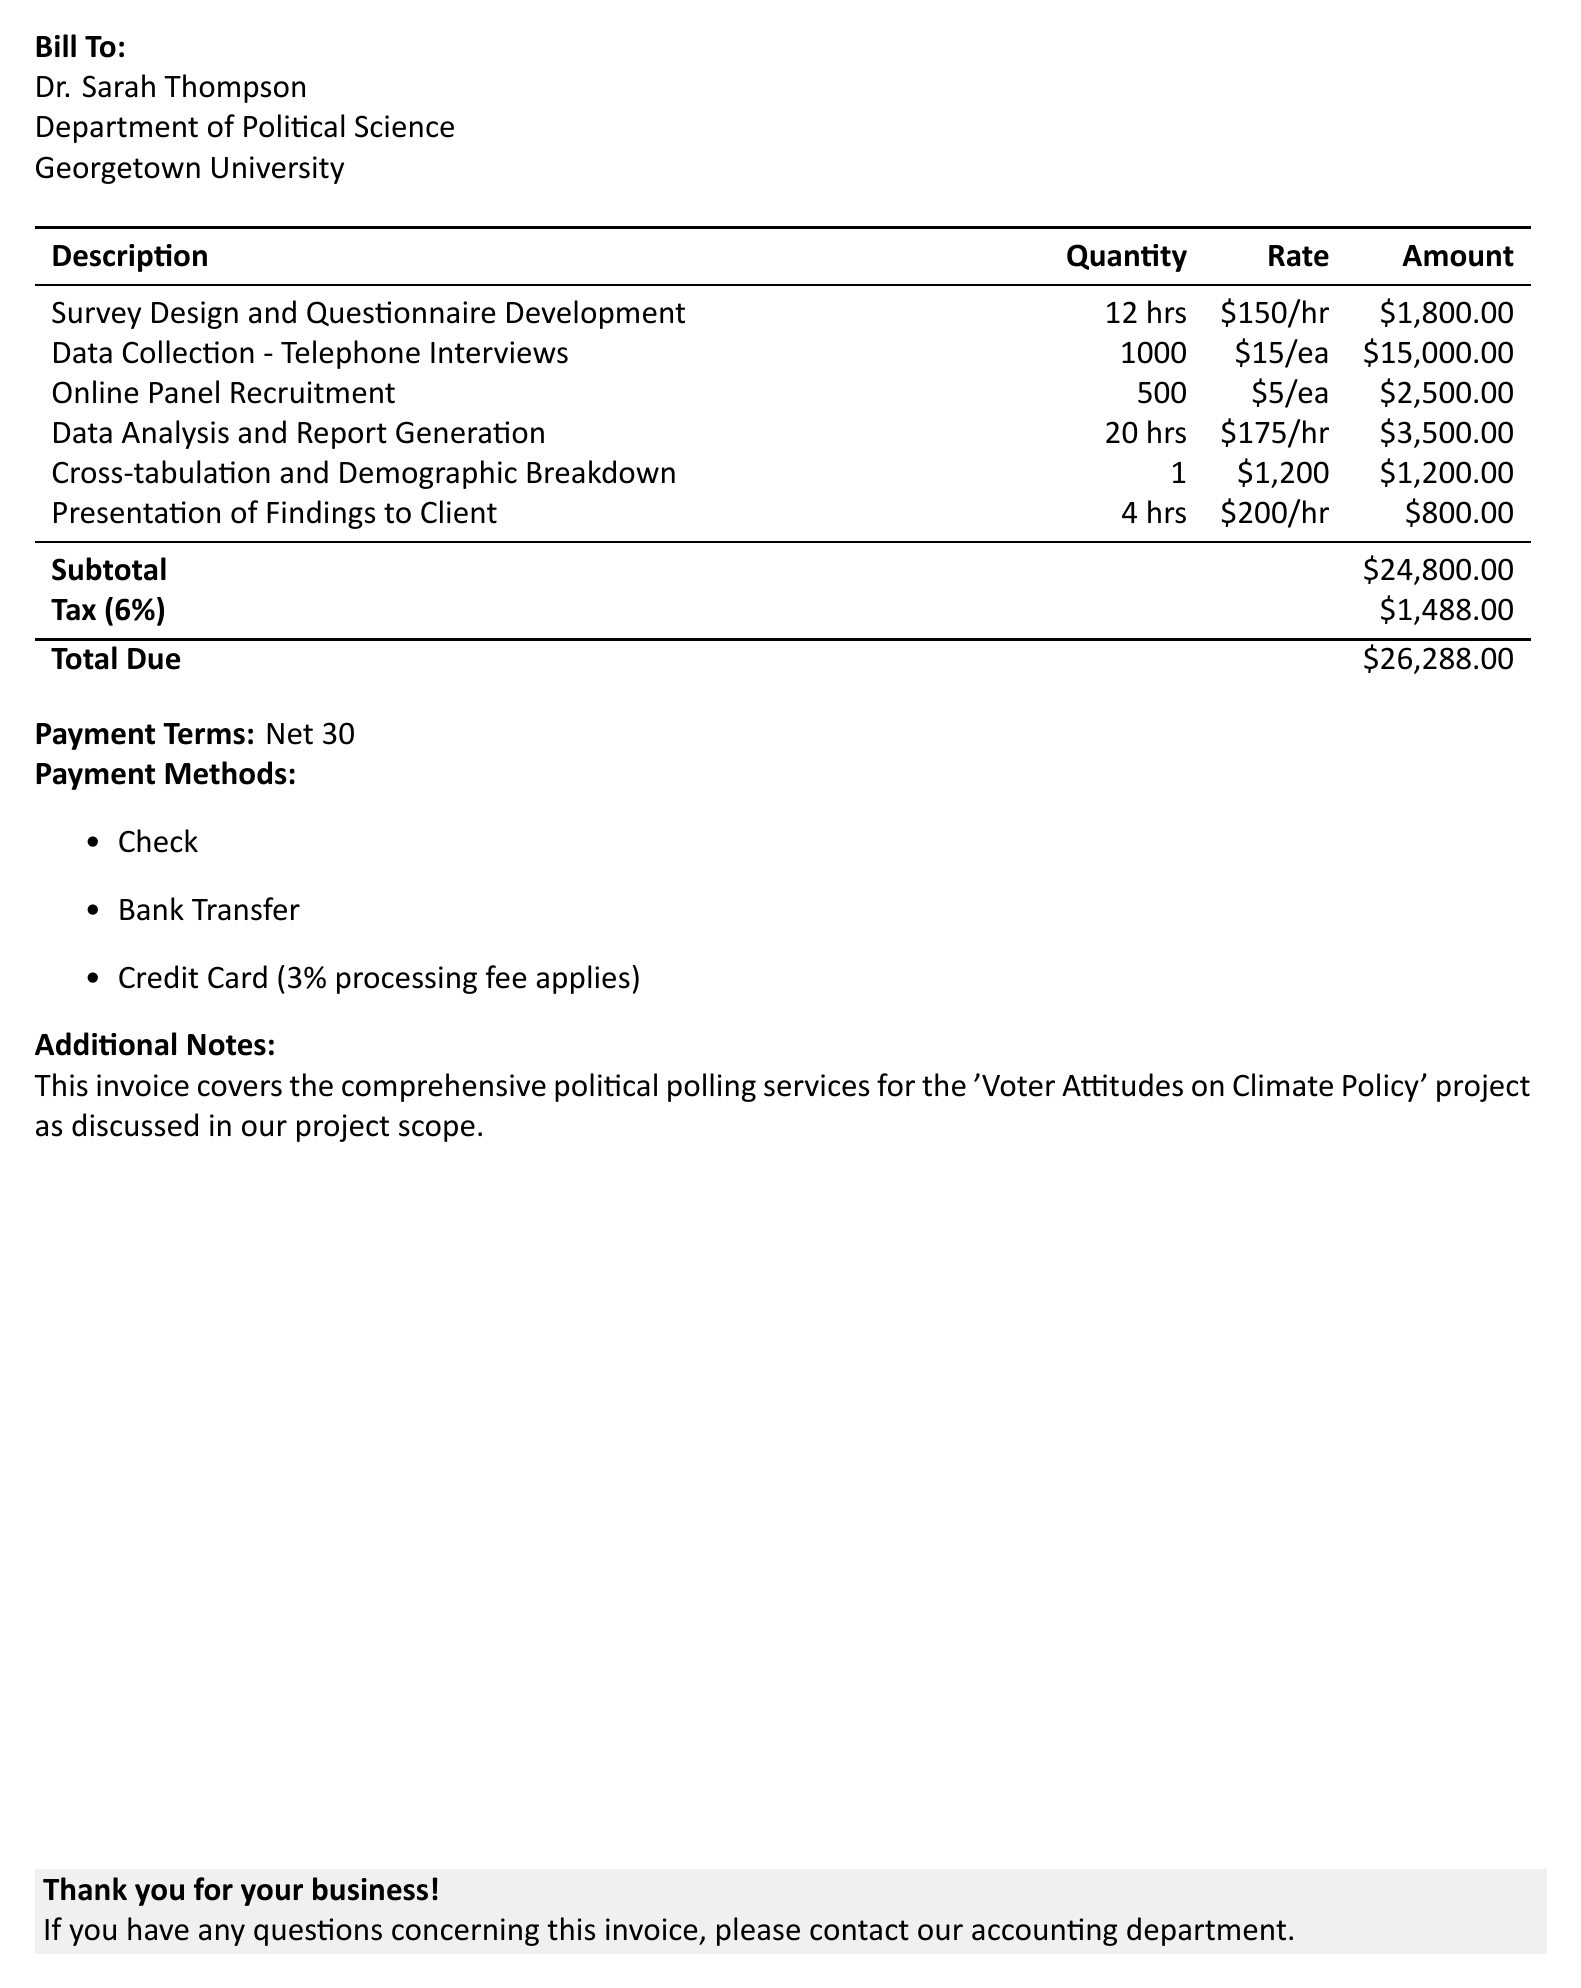What is the invoice number? The invoice number is specified in the document as part of the billing information.
Answer: PI-2023-0542 What is the due date for the payment? The due date can be found in the invoice section, indicating when payment is expected.
Answer: June 14, 2023 Who is the bill addressed to? The document specifies the recipient of the bill, which is crucial for identifying the client.
Answer: Dr. Sarah Thompson How many hours were dedicated to data analysis and report generation? This detail is included in the description of services provided within the invoice.
Answer: 20 hrs What is the subtotal of the invoice before tax? The subtotal represents the total of all services rendered before any additional costs are added.
Answer: $24,800.00 What percentage is applied for tax on the total amount? The tax rate is explicitly mentioned alongside the subtotal in the invoice section.
Answer: 6% What is the total amount due including tax? The total due combines the subtotal and tax, showing the final amount payable.
Answer: $26,288.00 What are the payment methods accepted? This information informs the client about how they can make their payment.
Answer: Check, Bank Transfer, Credit Card (3% processing fee applies) How many telephone interviews were conducted? This number indicates the scale of the data collection process and is listed in the services section.
Answer: 1000 